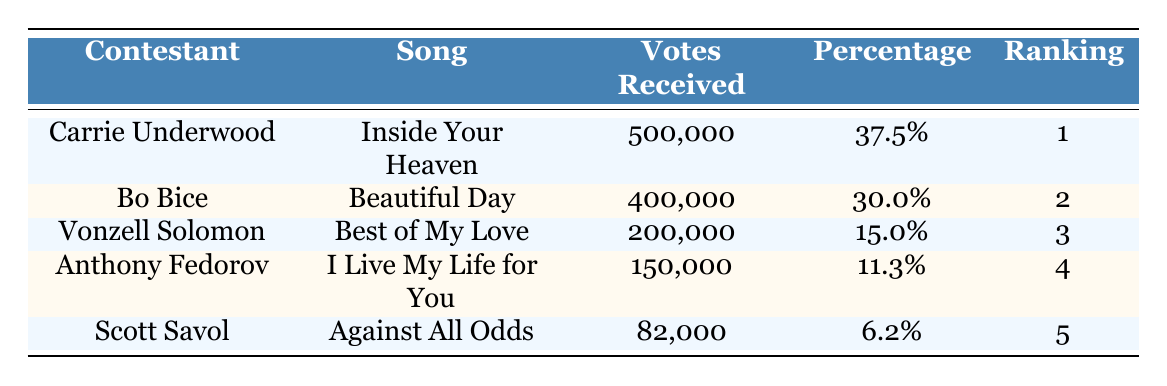What is the total number of votes received by all contestants? To find the total votes, we add the votes received by each contestant: 500,000 + 400,000 + 200,000 + 150,000 + 82,000 = 1,332,000.
Answer: 1,332,000 Which contestant received the highest percentage of votes? The highest percentage of votes is found by comparing the percentages for each contestant. Carrie Underwood has 37.5%, which is higher than all others.
Answer: Carrie Underwood How many contestants received more than 200,000 votes? By checking the "Votes Received" column, we see that Carrie Underwood (500,000) and Bo Bice (400,000) received more than 200,000 votes. This counts as two contestants.
Answer: 2 Is it true that Anthony Fedorov received more votes than Scott Savol? To determine this, we compare the votes received. Anthony Fedorov received 150,000 votes, while Scott Savol received 82,000 votes; hence, Anthony Fedorov did receive more.
Answer: Yes What is the average number of votes received by the contestants in the rankings 2 to 4? The contestants in rankings 2 to 4 are Bo Bice (400,000), Vonzell Solomon (200,000), and Anthony Fedorov (150,000). Adding these gives 400,000 + 200,000 + 150,000 = 750,000. Dividing by the number of contestants, which is 3, gives us an average of 750,000 / 3 = 250,000.
Answer: 250,000 Which contestant had the fewest votes and what was the percentage? From the "Votes Received" column, Scott Savol received the fewest votes, which is 82,000. Referring to the "Percentage" column, it shows he had 6.2%.
Answer: Scott Savol, 6.2% What is the difference in votes between the first and last ranked contestants? Carrie Underwood (1st) received 500,000 votes, and Scott Savol (5th) received 82,000 votes. The difference is calculated as 500,000 - 82,000 = 418,000.
Answer: 418,000 Did any contestant receive exactly 15% of the total votes? Total votes are 1,332,000. Calculating 15% of this amount, we find that 15% equals 199,800. Checking the votes received, Vonzell Solomon, who received 200,000, is not exactly 15%, so no contestant received exactly this percentage.
Answer: No 